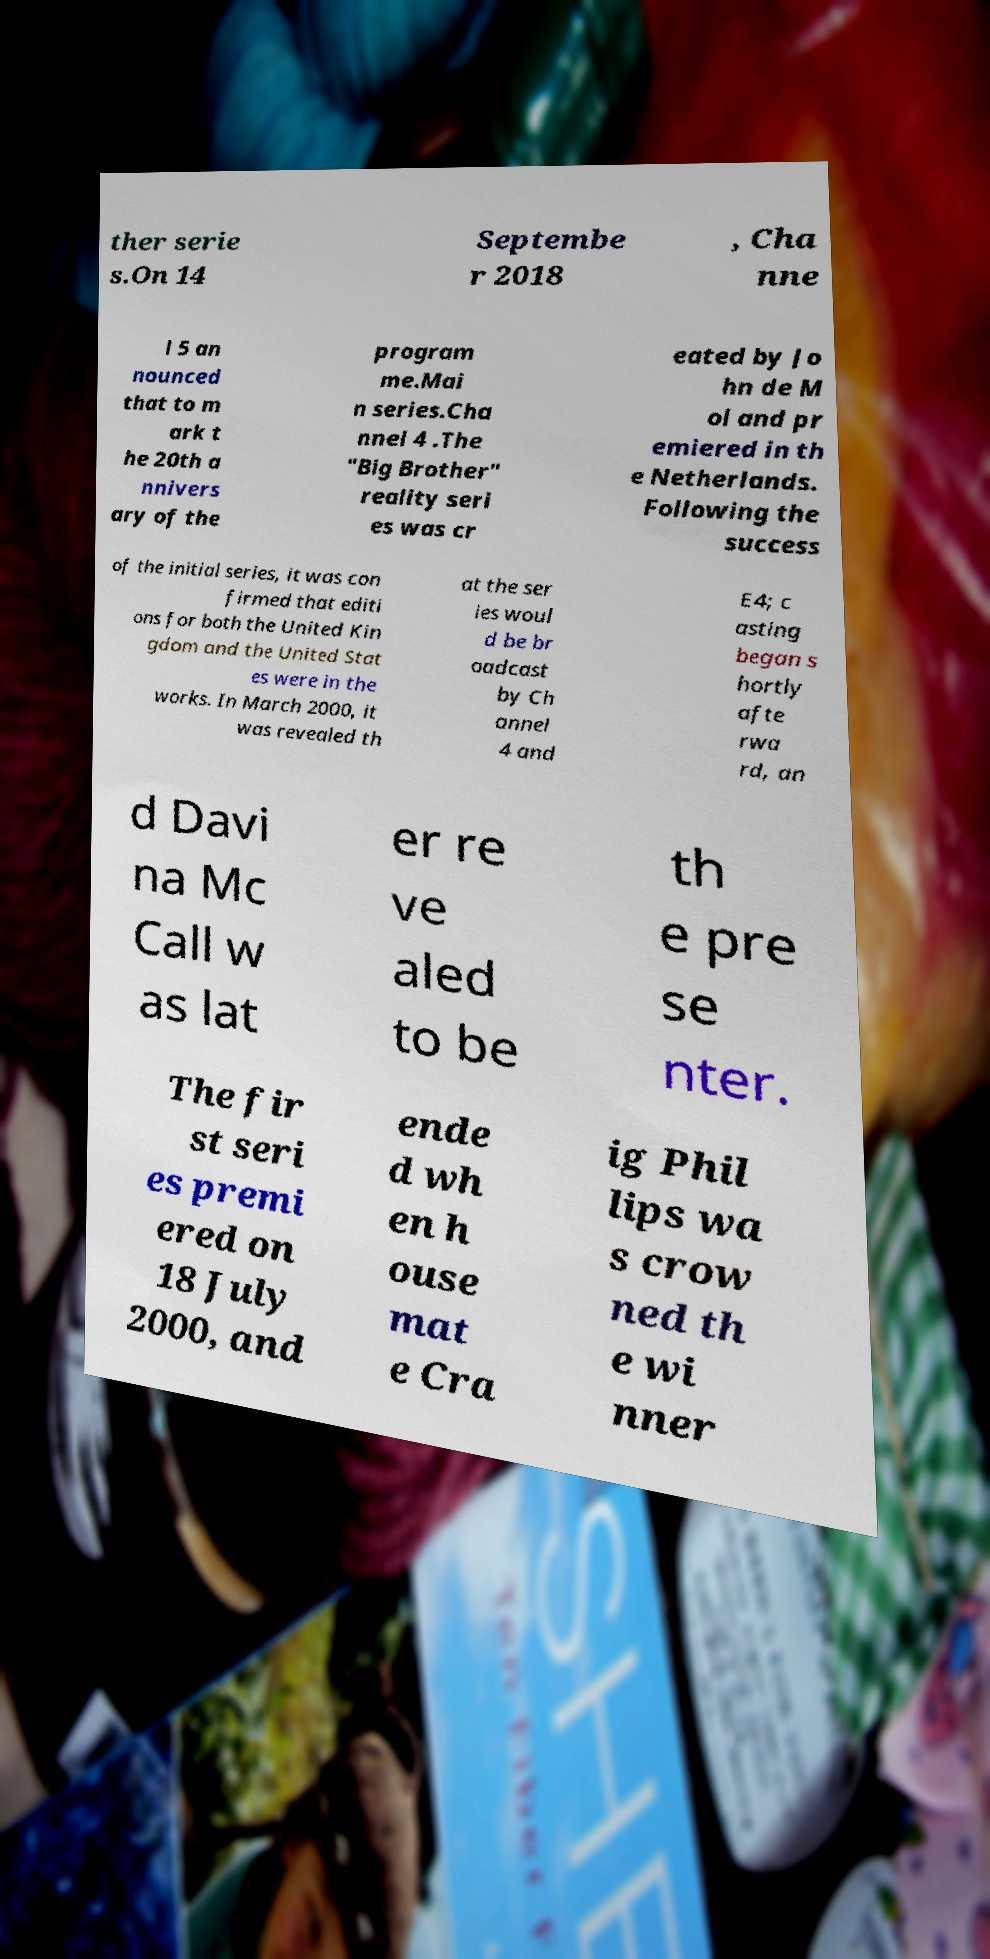Could you extract and type out the text from this image? ther serie s.On 14 Septembe r 2018 , Cha nne l 5 an nounced that to m ark t he 20th a nnivers ary of the program me.Mai n series.Cha nnel 4 .The "Big Brother" reality seri es was cr eated by Jo hn de M ol and pr emiered in th e Netherlands. Following the success of the initial series, it was con firmed that editi ons for both the United Kin gdom and the United Stat es were in the works. In March 2000, it was revealed th at the ser ies woul d be br oadcast by Ch annel 4 and E4; c asting began s hortly afte rwa rd, an d Davi na Mc Call w as lat er re ve aled to be th e pre se nter. The fir st seri es premi ered on 18 July 2000, and ende d wh en h ouse mat e Cra ig Phil lips wa s crow ned th e wi nner 